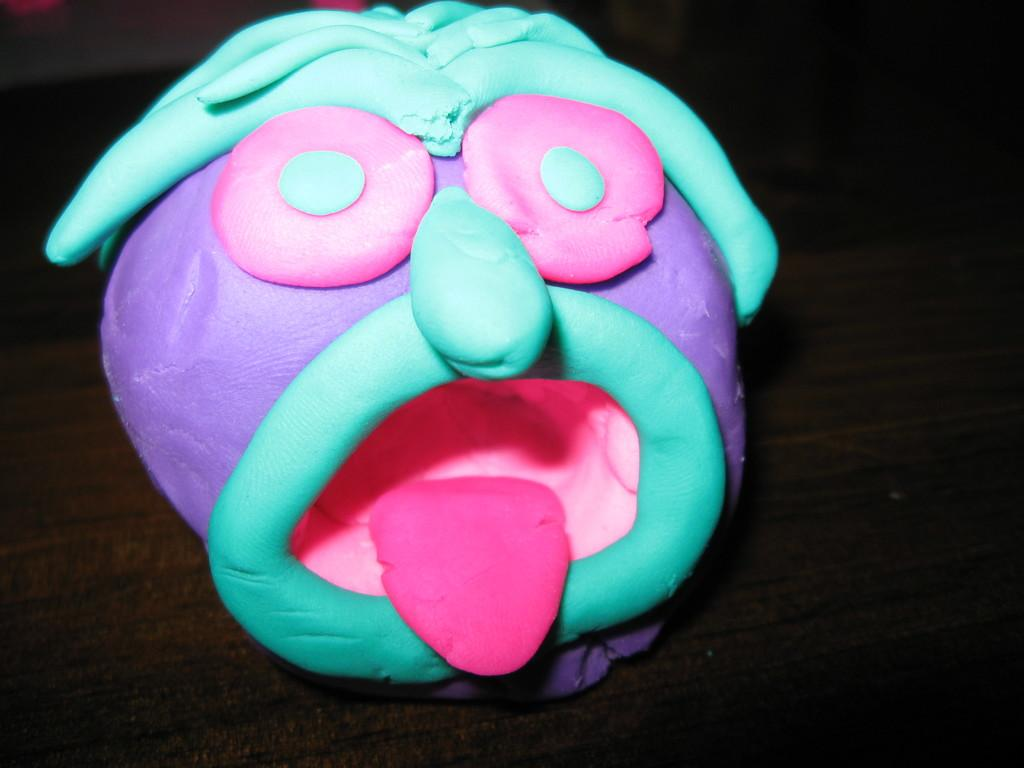What is the main subject of the image? There is a cake in the image. Where is the cake located in the image? The cake is in the middle of the image. What can be observed about the background of the image? The background of the image is dark. What is the plot of the cake in the image? There is no plot associated with the cake in the image, as it is a static object. 